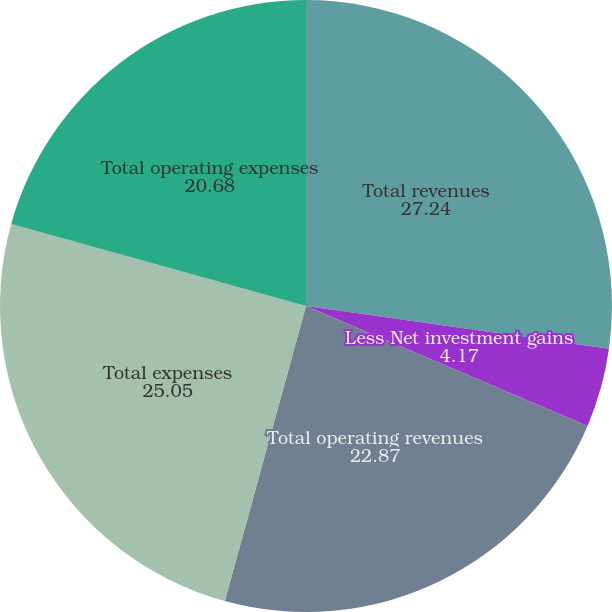Convert chart. <chart><loc_0><loc_0><loc_500><loc_500><pie_chart><fcel>Total revenues<fcel>Less Net investment gains<fcel>Total operating revenues<fcel>Total expenses<fcel>Total operating expenses<nl><fcel>27.24%<fcel>4.17%<fcel>22.87%<fcel>25.05%<fcel>20.68%<nl></chart> 